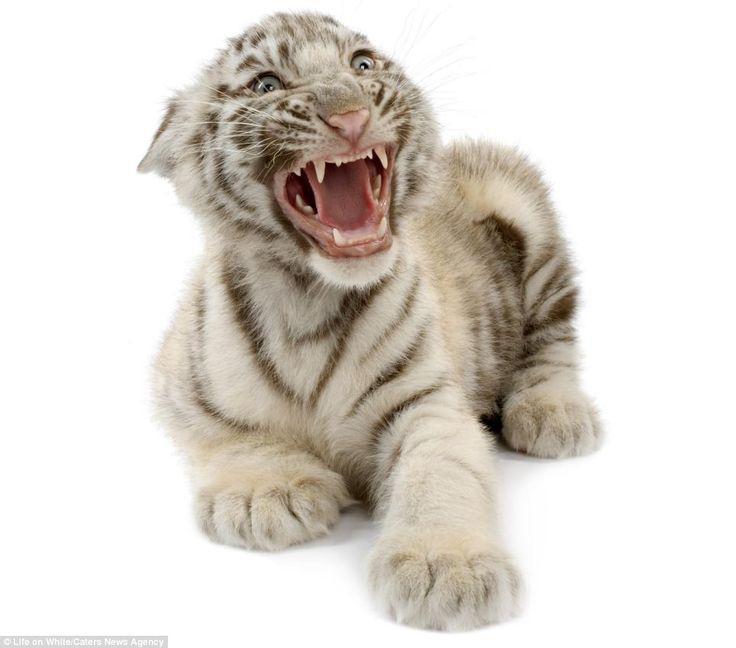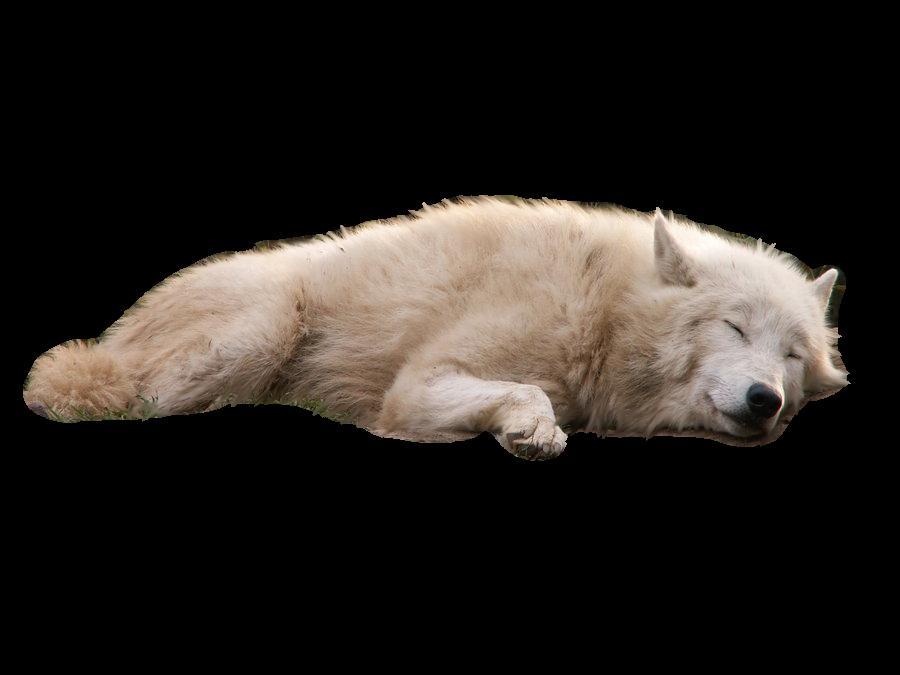The first image is the image on the left, the second image is the image on the right. Given the left and right images, does the statement "The left and right image contains the same number of wolves." hold true? Answer yes or no. No. 